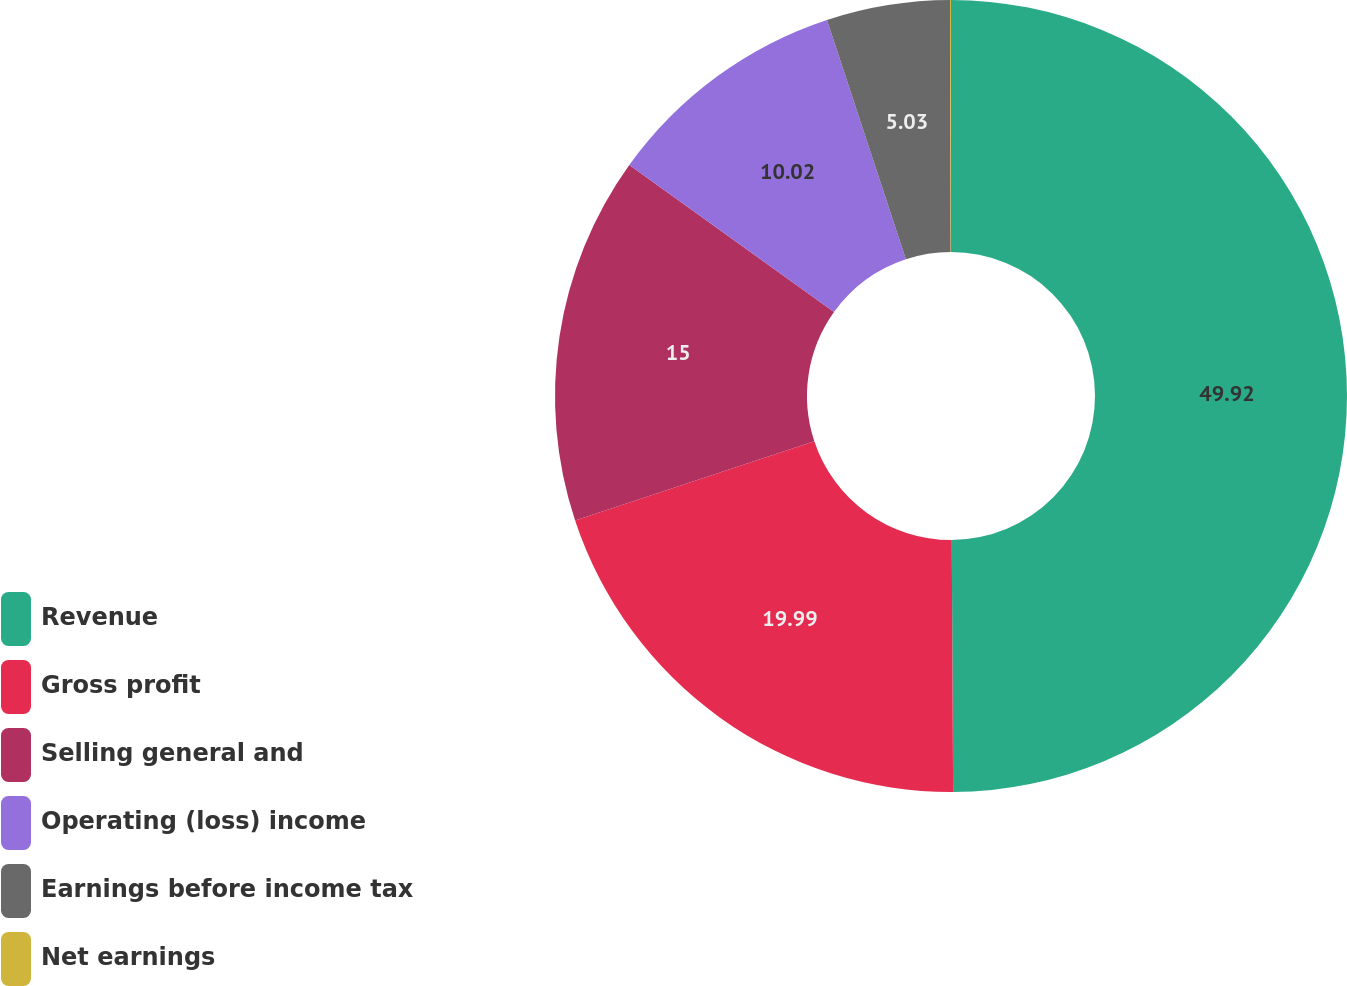Convert chart to OTSL. <chart><loc_0><loc_0><loc_500><loc_500><pie_chart><fcel>Revenue<fcel>Gross profit<fcel>Selling general and<fcel>Operating (loss) income<fcel>Earnings before income tax<fcel>Net earnings<nl><fcel>49.91%<fcel>19.99%<fcel>15.0%<fcel>10.02%<fcel>5.03%<fcel>0.04%<nl></chart> 